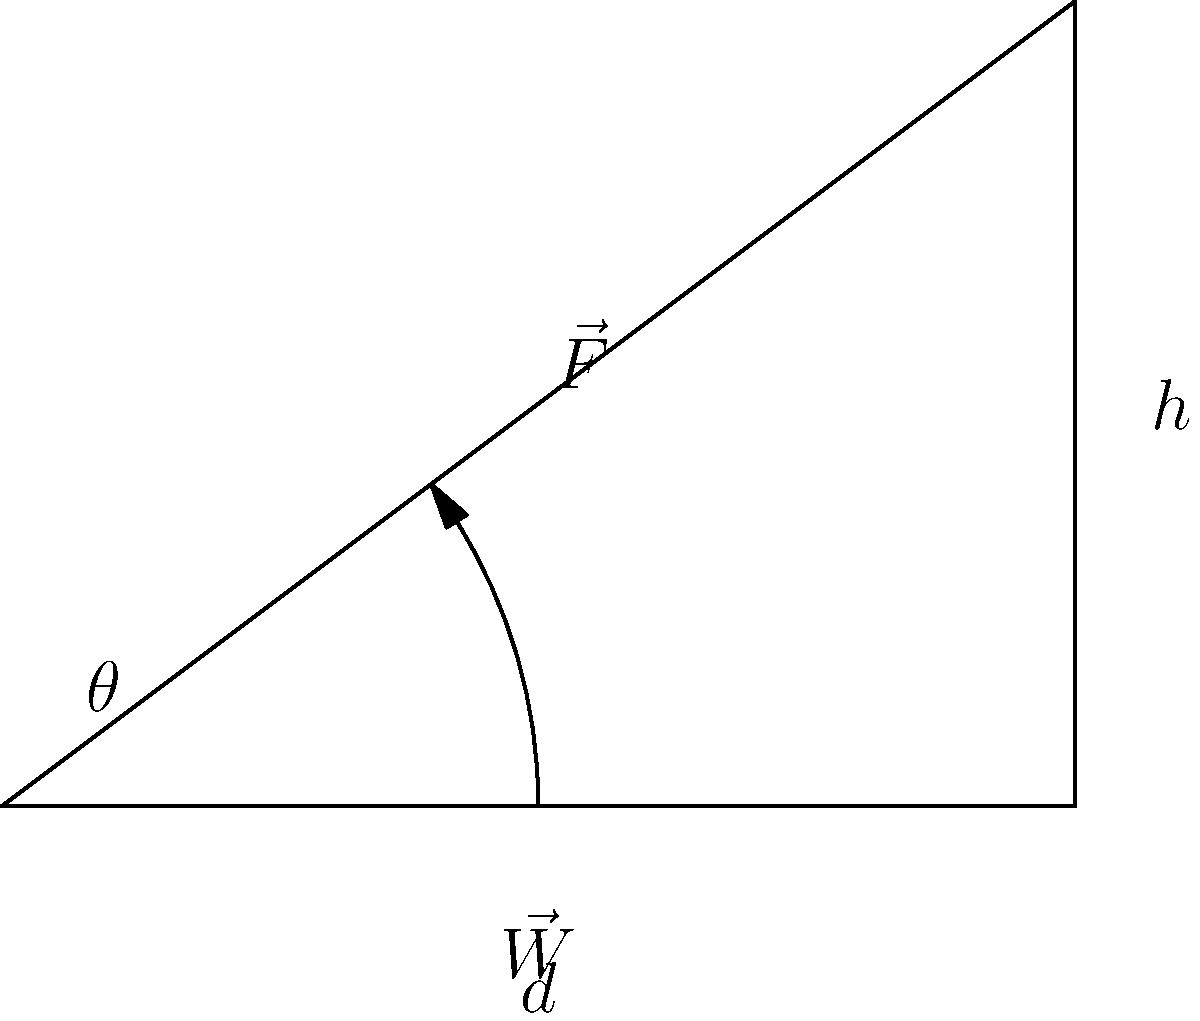In your gym, you're setting up an incline bench press station. Using the vector diagram provided, determine the optimal angle $\theta$ for maximum muscle engagement. Given that the weight vector $\vec{W}$ is perpendicular to the ground and the force vector $\vec{F}$ is parallel to the bench, calculate $\theta$ if the bench height $h$ is 3 feet and its length $d$ is 4 feet. To find the optimal angle $\theta$, we'll use the principles of analytic geometry:

1) First, we recognize that the bench forms a right triangle with the floor and the vertical support.

2) We can use the tangent function to relate the angle to the height and length:

   $\tan(\theta) = \frac{\text{opposite}}{\text{adjacent}} = \frac{h}{d}$

3) Substituting the given values:

   $\tan(\theta) = \frac{3 \text{ feet}}{4 \text{ feet}} = 0.75$

4) To find $\theta$, we need to take the inverse tangent (arctangent):

   $\theta = \tan^{-1}(0.75)$

5) Using a calculator or trigonometric tables:

   $\theta \approx 36.87°$

This angle provides an optimal balance between vertical and horizontal force components, engaging both the chest and shoulder muscles effectively.
Answer: $36.87°$ 